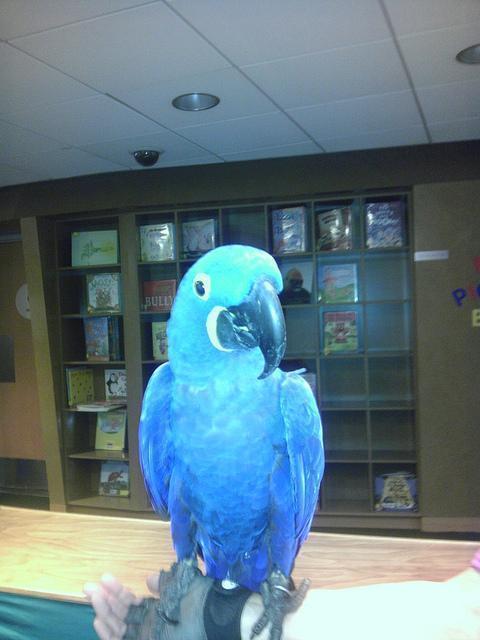Why is the person holding the bird wearing a glove?
Pick the correct solution from the four options below to address the question.
Options: Fashion, for work, warmth, protection. Protection. 